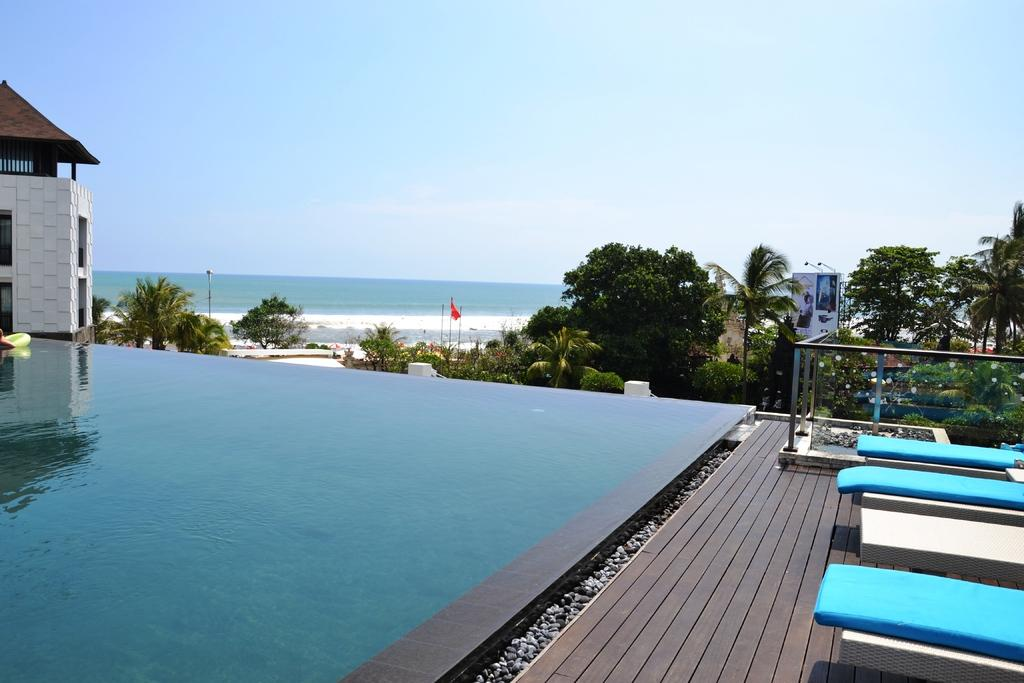What is the main feature in the image? There is a swimming pool in the image. What structure is located on the left side of the image? There is a house on the left side of the image. What type of vegetation is present in the image? There are green color trees in the image. What is visible at the top of the image? The sky is visible at the top of the image. Where is the hospital located in the image? There is no hospital present in the image. What type of wheel can be seen on the stage in the image? There is no stage or wheel present in the image. 